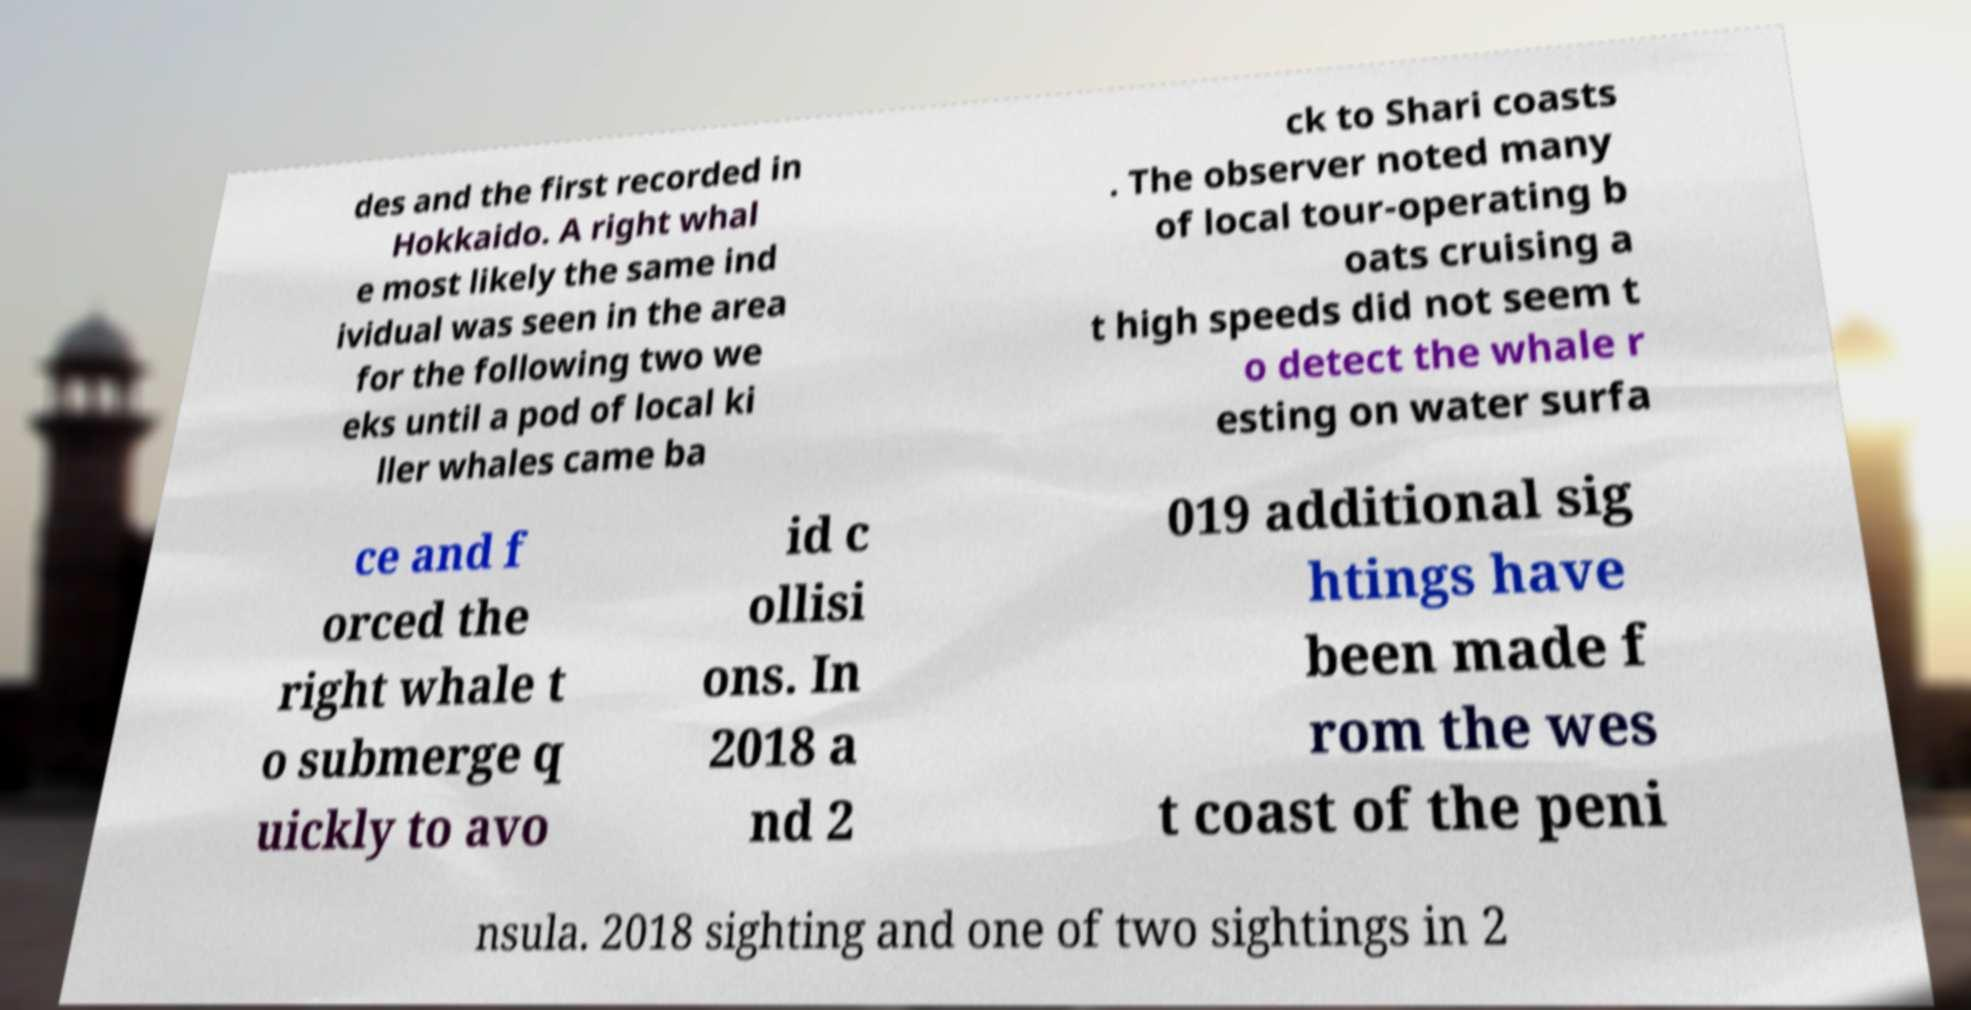Please read and relay the text visible in this image. What does it say? des and the first recorded in Hokkaido. A right whal e most likely the same ind ividual was seen in the area for the following two we eks until a pod of local ki ller whales came ba ck to Shari coasts . The observer noted many of local tour-operating b oats cruising a t high speeds did not seem t o detect the whale r esting on water surfa ce and f orced the right whale t o submerge q uickly to avo id c ollisi ons. In 2018 a nd 2 019 additional sig htings have been made f rom the wes t coast of the peni nsula. 2018 sighting and one of two sightings in 2 